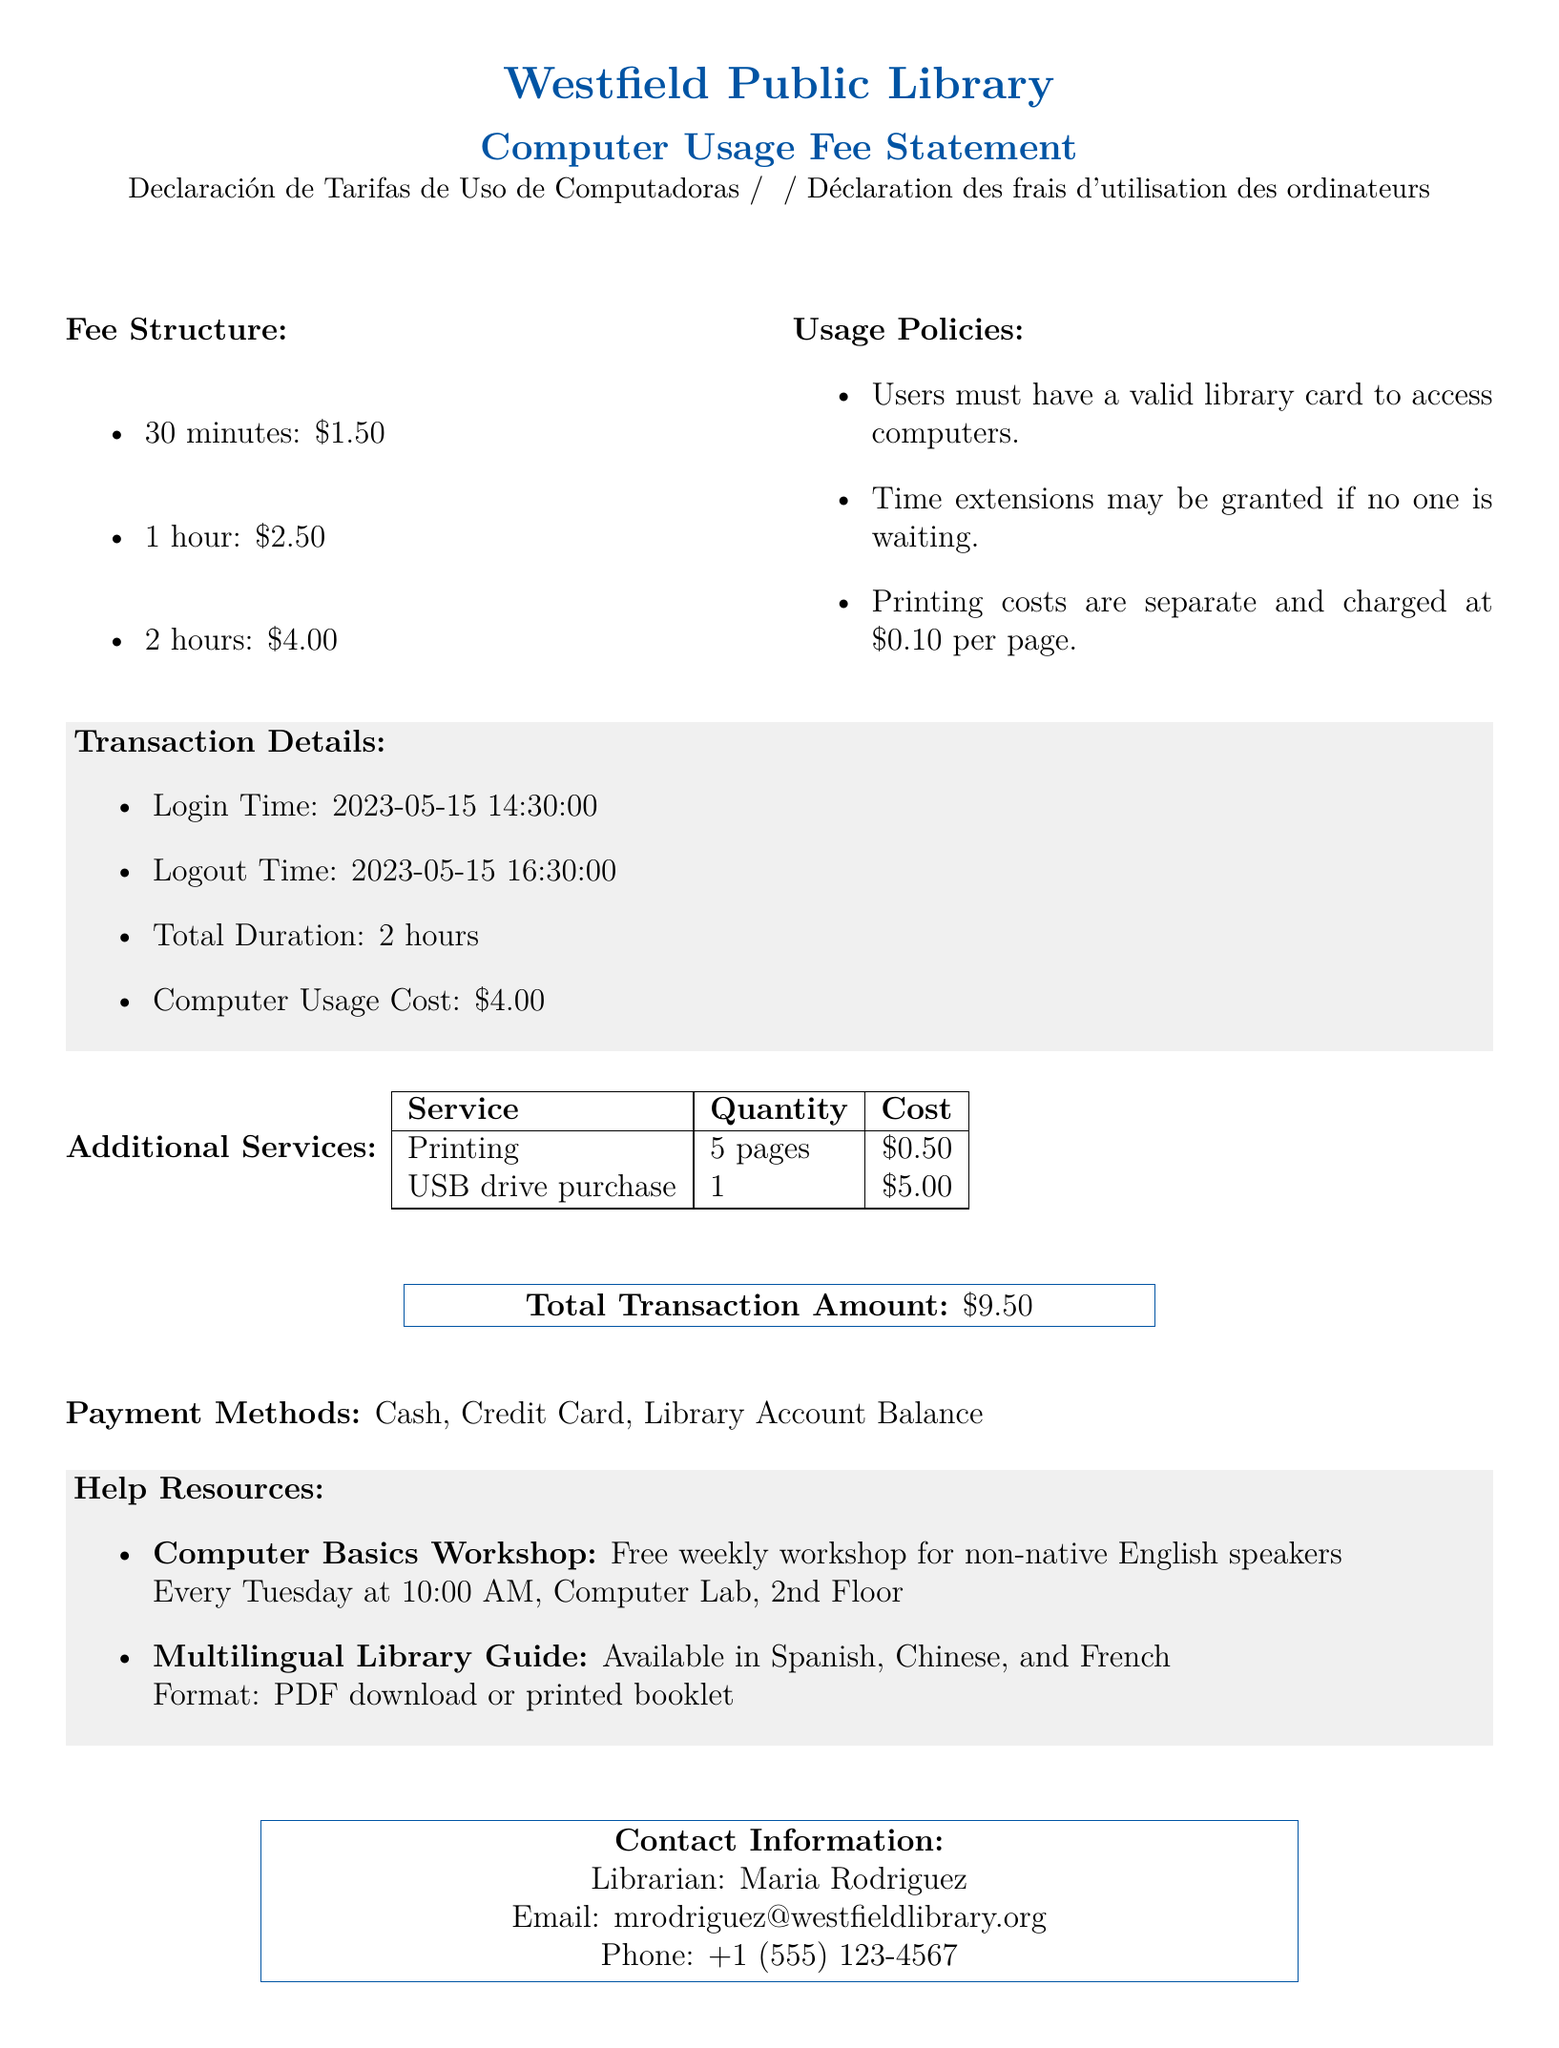What is the name of the library? The library's name is mentioned at the top of the document.
Answer: Westfield Public Library What is the cost for 2 hours of computer usage? The fee structure specifies the cost for 2 hours.
Answer: $4.00 When was the login time for the computer session? The specific login time is provided in the transaction details.
Answer: 2023-05-15 14:30:00 How many pages were printed during the transaction? The additional services section provides the quantity of pages printed.
Answer: 5 pages What is the total transaction amount? The total amount of the transaction is clearly stated at the end of the document.
Answer: $9.50 What must users have to access the computers? The usage policies outline the requirements for access to computers.
Answer: a valid library card Which workshop is offered for non-native English speakers? The help resources list specific workshops available for assistance.
Answer: Computer Basics Workshop What is the cost per printed page? The usage policies provide the cost per page for printing.
Answer: $0.10 What payment methods are accepted? The document specifies the available methods of payment at the end.
Answer: Cash, Credit Card, Library Account Balance 